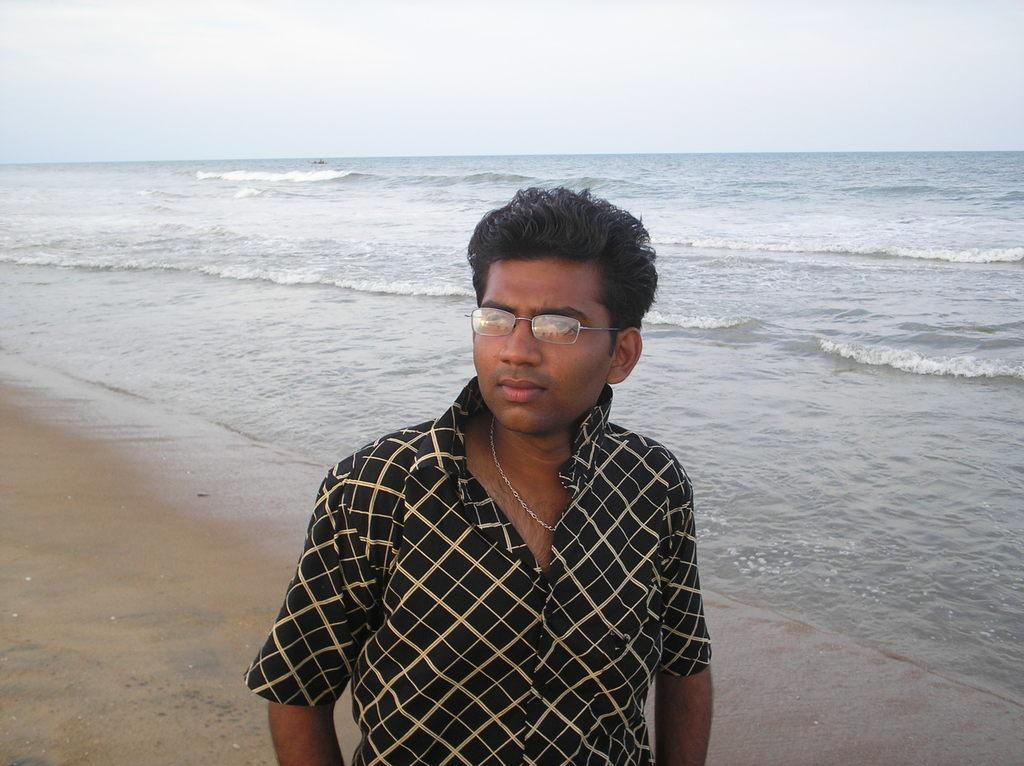Who or what is present in the image? There is a person in the image. What is the person wearing? The person is wearing a black and cream color shirt. What can be seen in the background of the image? There is a sea and the sky visible in the background of the image. What are the colors of the sky in the image? The sky in the image has colors of white and blue. What type of pest can be seen crawling on the person's shirt in the image? There are no pests visible on the person's shirt in the image. What kind of test is the person taking in the image? There is no test being taken in the image; the person is simply standing in front of a sea and sky background. 